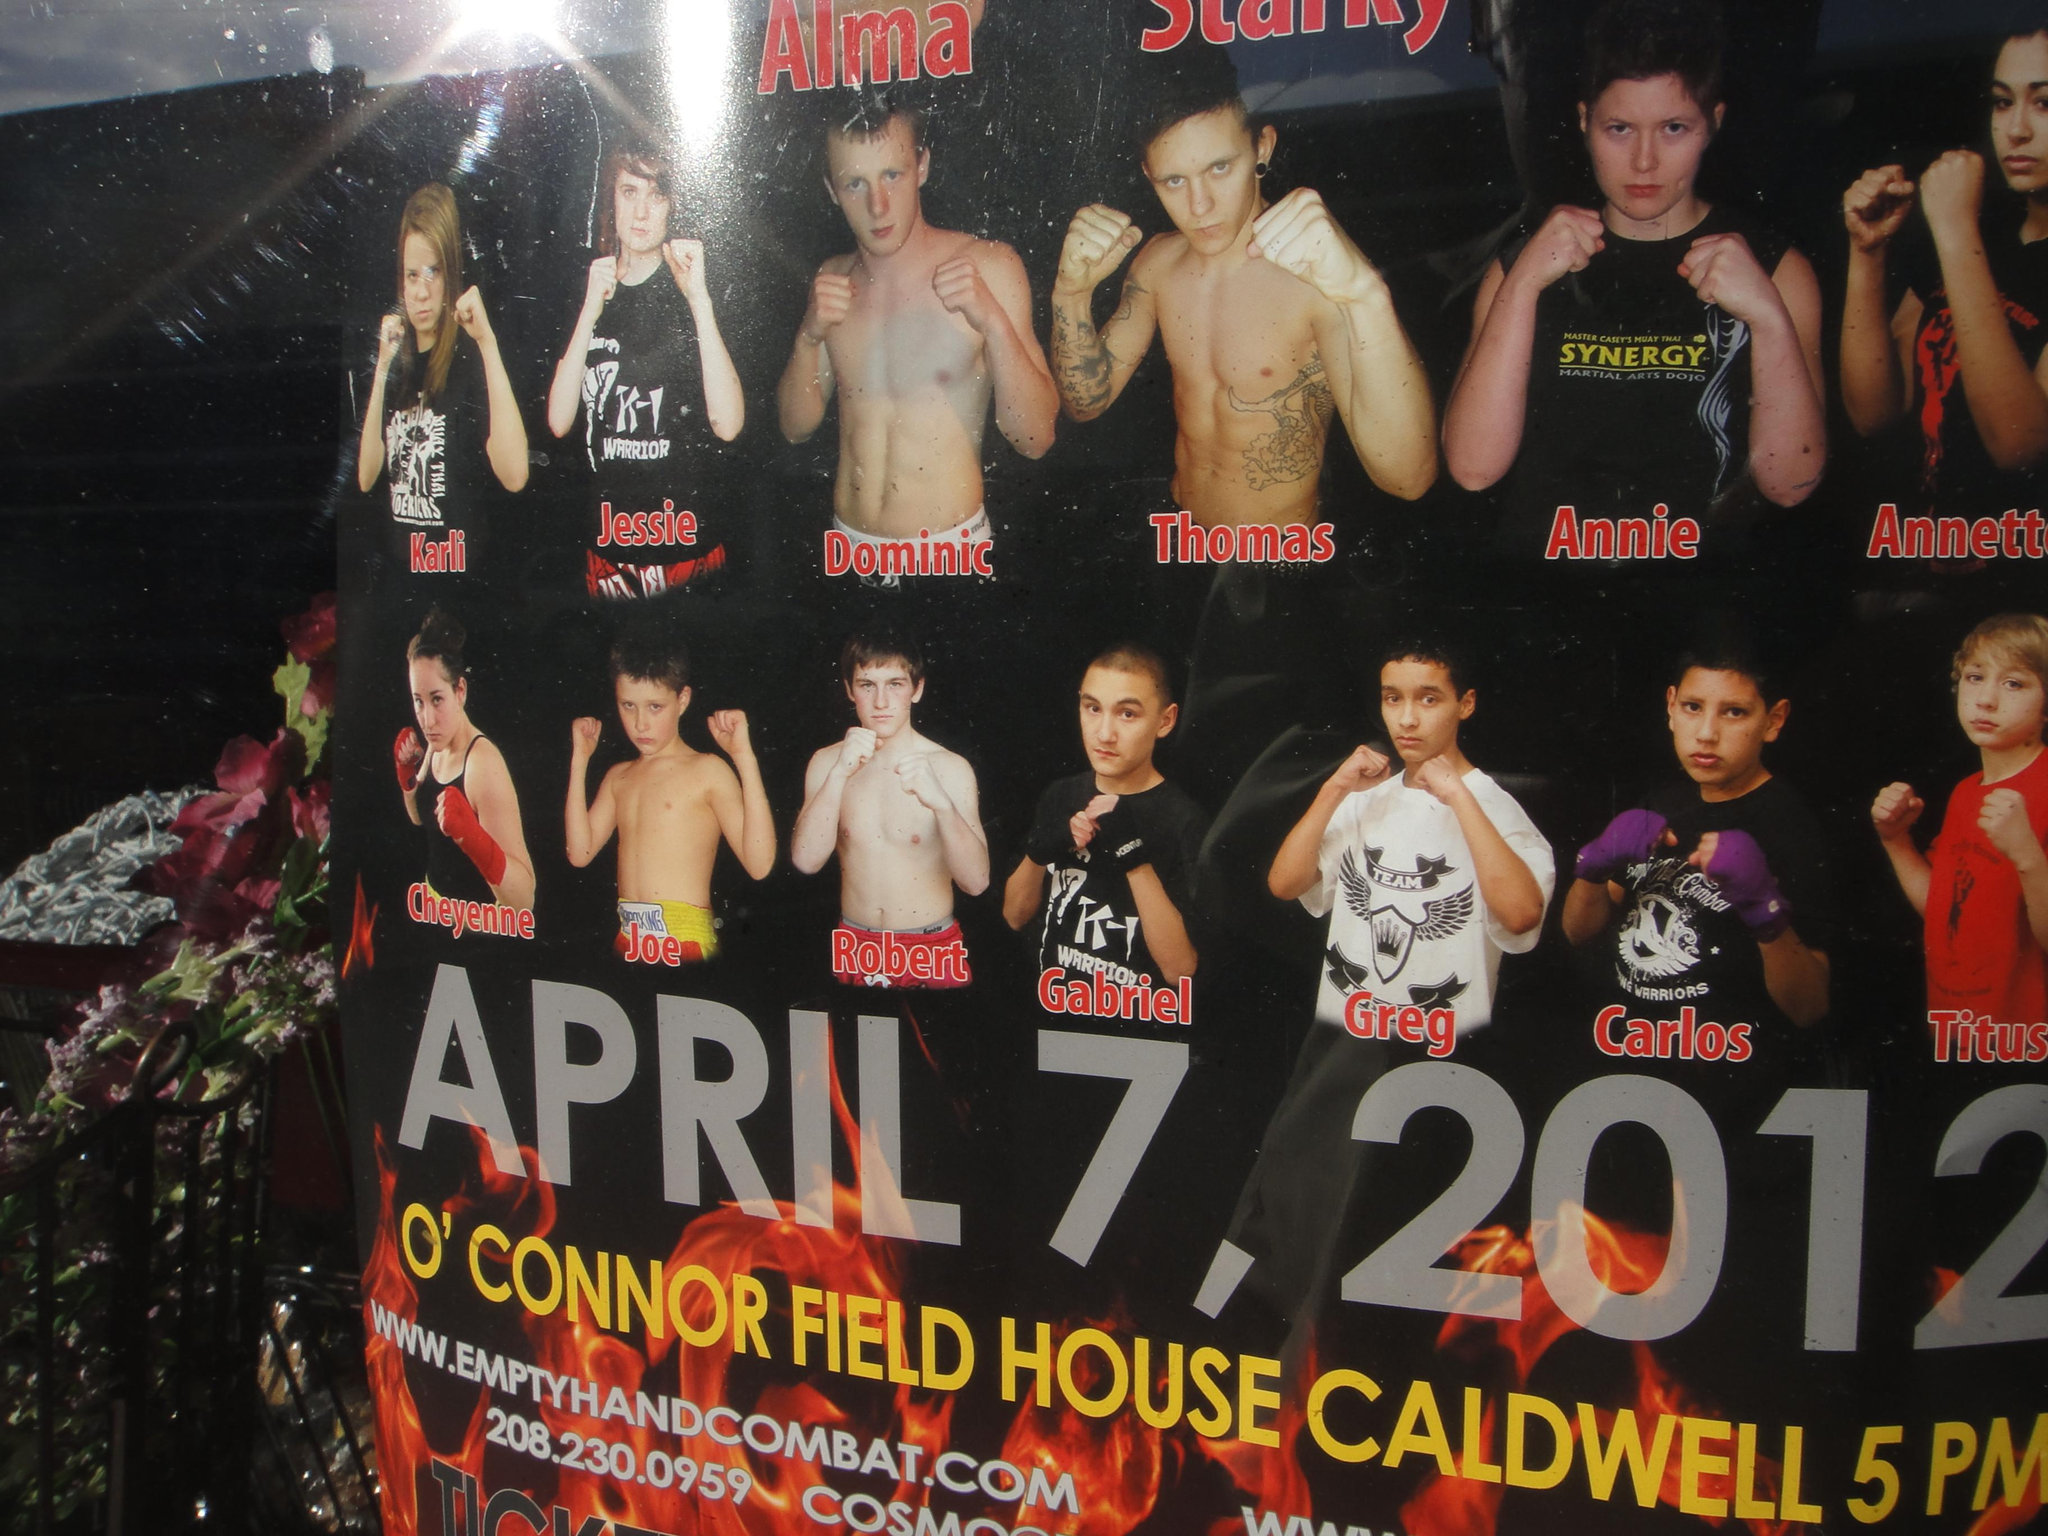What is featured on the poster in the image? There is a poster with text in the image, and it also has pictures of people on it. What else can be seen in the image besides the poster? There is a plant in the image. What is the source of light in the image? There is light on the ceiling in the image. What attempt does the society make to change the thing in the image? There is no reference to a society or an attempt to change anything in the image. The image features a poster with text, pictures of people, a plant, and light on the ceiling. 